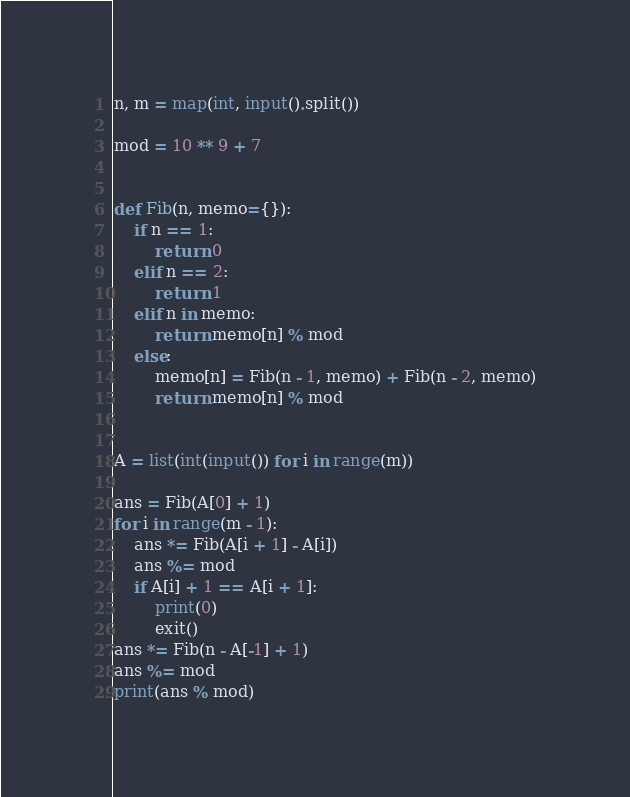<code> <loc_0><loc_0><loc_500><loc_500><_Python_>n, m = map(int, input().split())

mod = 10 ** 9 + 7


def Fib(n, memo={}):
    if n == 1:
        return 0
    elif n == 2:
        return 1
    elif n in memo:
        return memo[n] % mod
    else:
        memo[n] = Fib(n - 1, memo) + Fib(n - 2, memo)
        return memo[n] % mod


A = list(int(input()) for i in range(m))

ans = Fib(A[0] + 1)
for i in range(m - 1):
    ans *= Fib(A[i + 1] - A[i])
    ans %= mod
    if A[i] + 1 == A[i + 1]:
        print(0)
        exit()
ans *= Fib(n - A[-1] + 1)
ans %= mod
print(ans % mod)</code> 